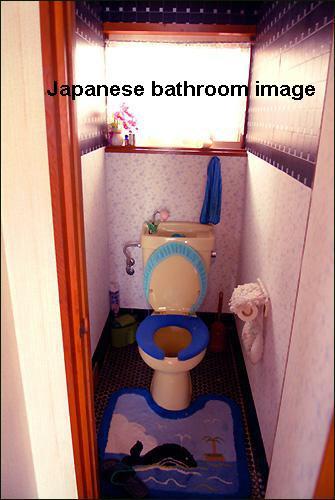What color is the toilet lid?
Keep it brief. Blue. What mammal is depicted on the rug?
Give a very brief answer. Whale. What country is the photo from?
Keep it brief. Japan. 